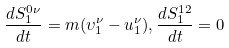<formula> <loc_0><loc_0><loc_500><loc_500>\frac { d S _ { 1 } ^ { 0 \nu } } { d t } = m ( \upsilon _ { 1 } ^ { \nu } - u _ { 1 } ^ { \nu } ) , \frac { d S _ { 1 } ^ { 1 2 } } { d t } = 0</formula> 